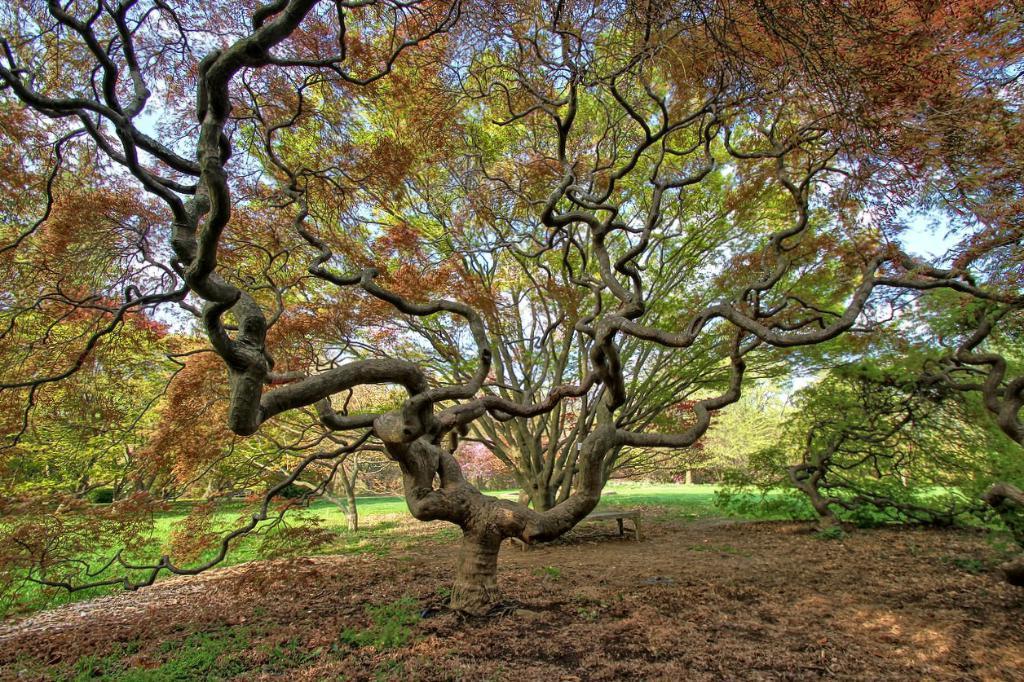How would you summarize this image in a sentence or two? In the image there are trees on the grassland. 